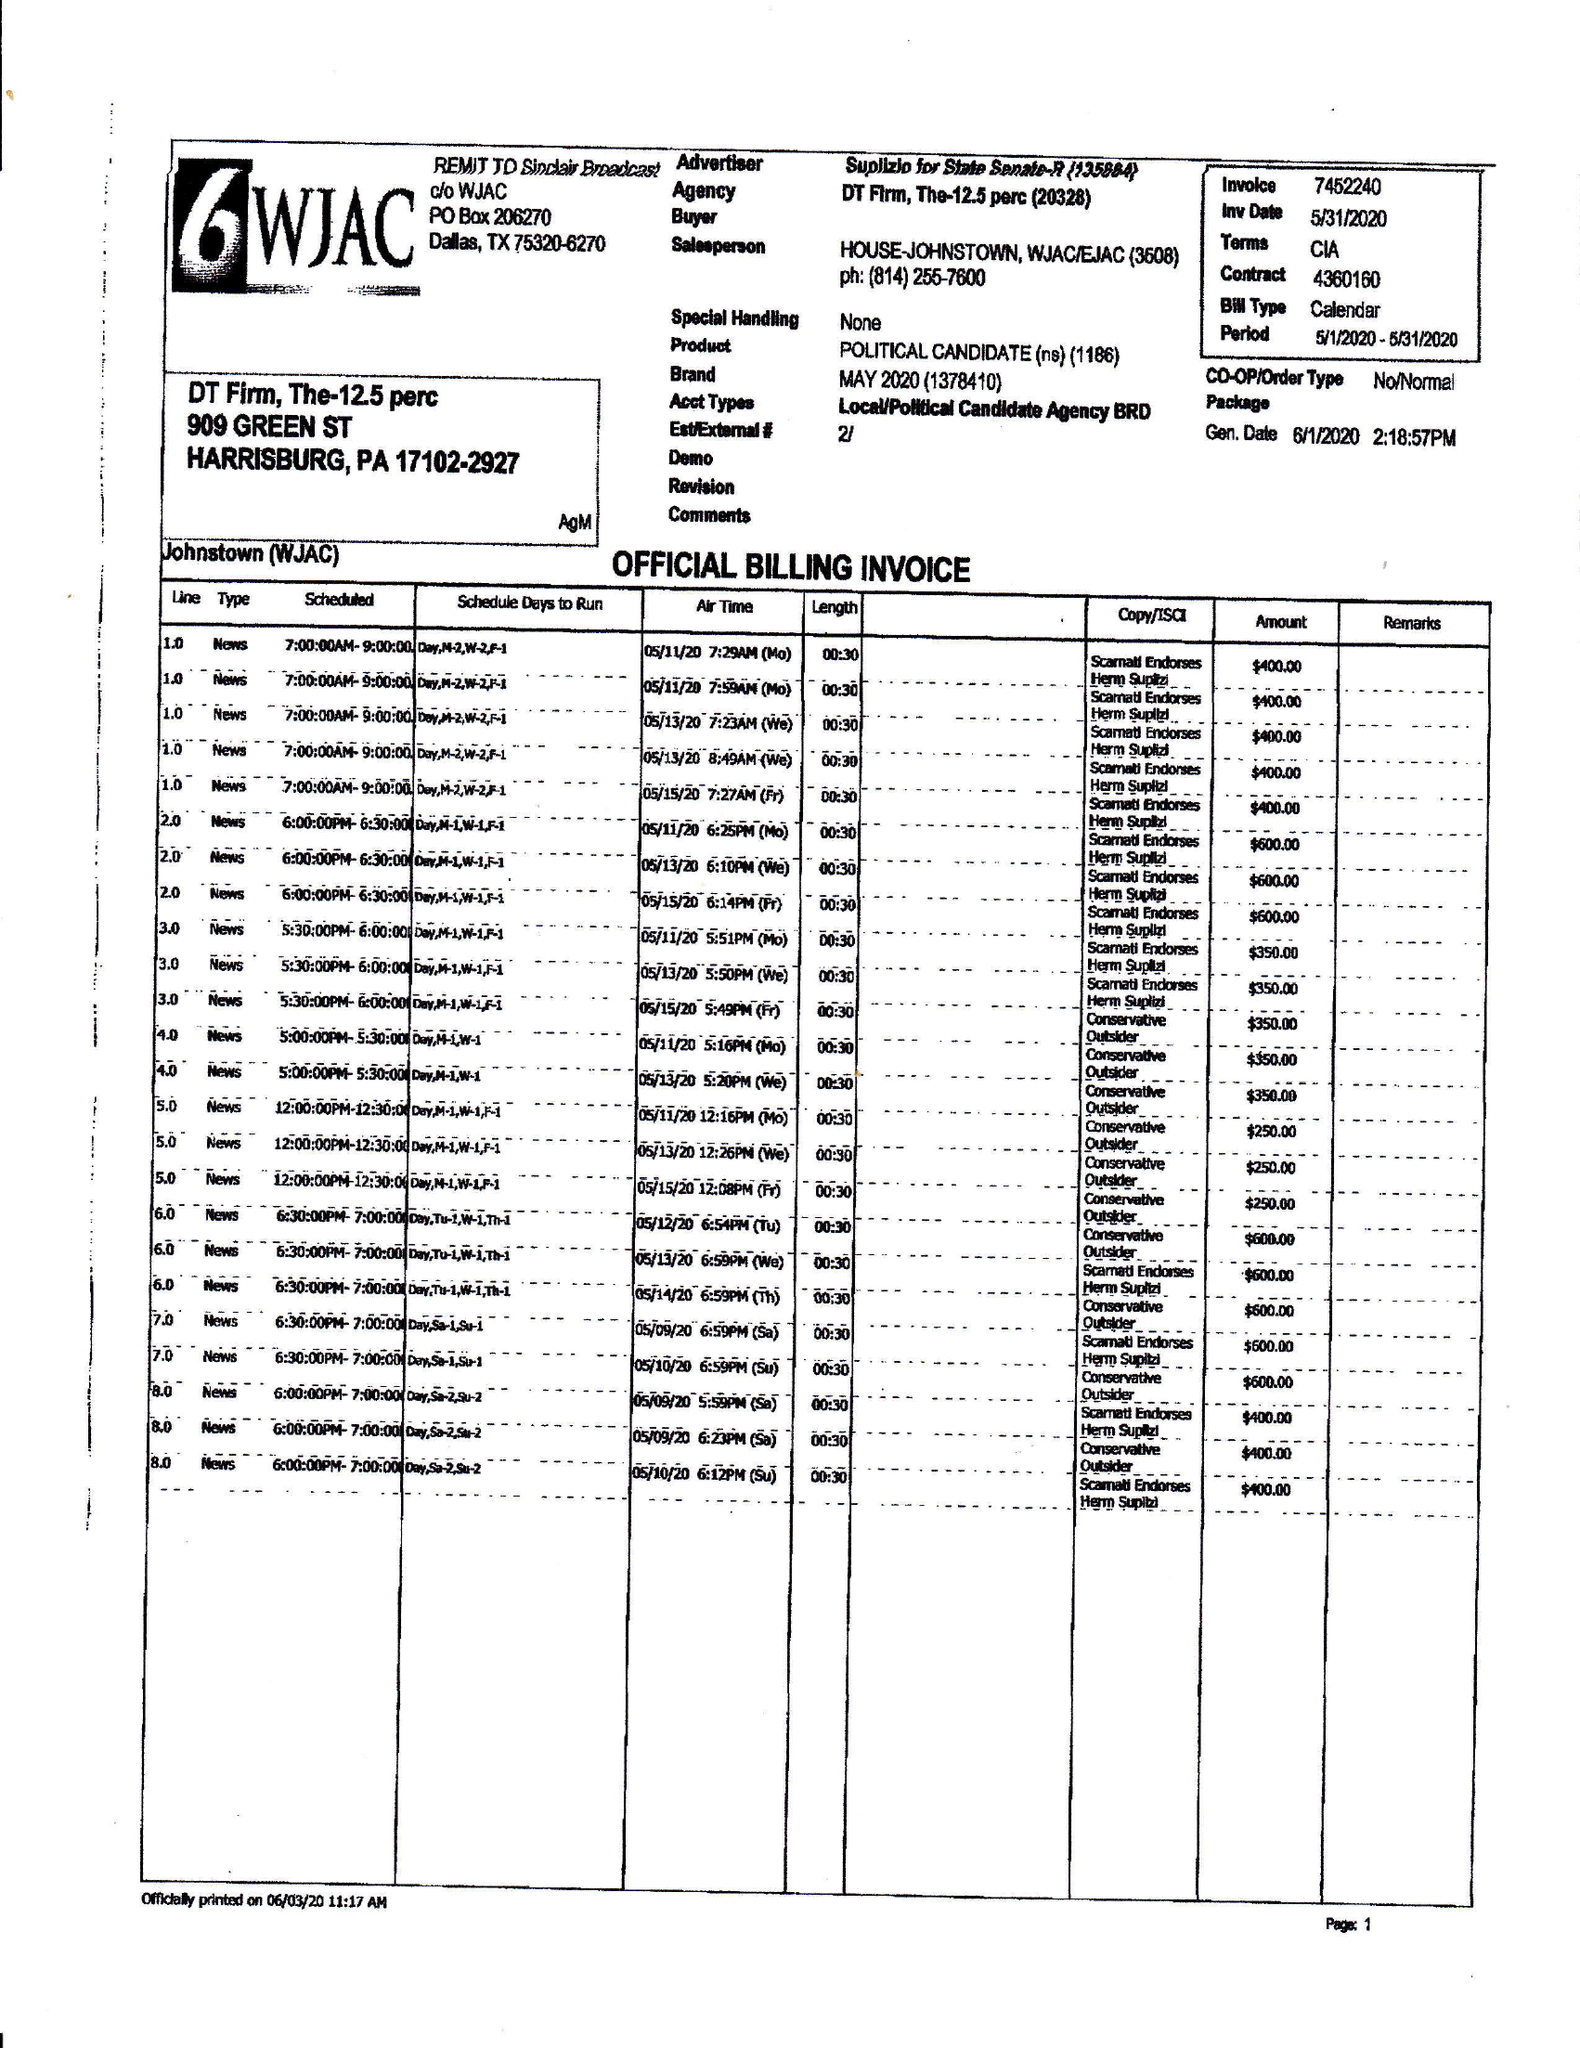What is the value for the gross_amount?
Answer the question using a single word or phrase. 17650.00 